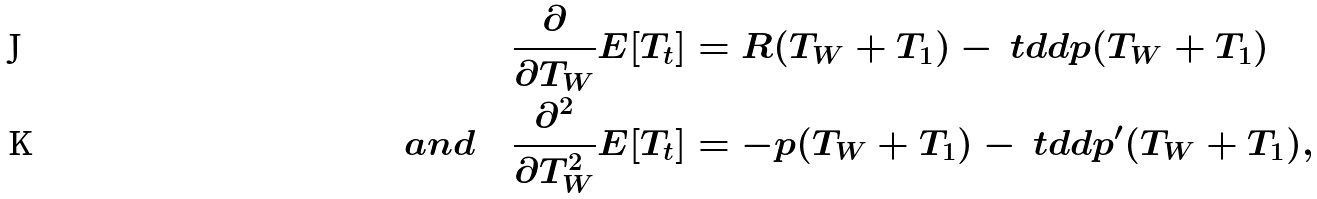<formula> <loc_0><loc_0><loc_500><loc_500>\frac { \partial } { \partial T _ { W } } E [ T _ { t } ] & = R ( T _ { W } + T _ { 1 } ) - \ t d d p ( T _ { W } + T _ { 1 } ) \\ a n d \quad \frac { \partial ^ { 2 } } { \partial T _ { W } ^ { 2 } } E [ T _ { t } ] & = - p ( T _ { W } + T _ { 1 } ) - \ t d d p ^ { \prime } ( T _ { W } + T _ { 1 } ) ,</formula> 